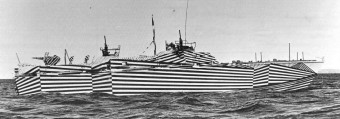What is the historical significance of the paint design on these boats? The striped patterns on these boats are known as 'dazzle camouflage' and were used during World War I. The primary purpose was not to conceal but to confuse the enemy, making it difficult to determine the ship's exact size, distance, and heading, which was crucial information for targeting. 